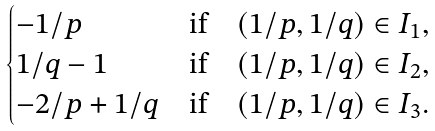Convert formula to latex. <formula><loc_0><loc_0><loc_500><loc_500>\begin{cases} - 1 / p & \text {if} \quad ( 1 / p , 1 / q ) \in I _ { 1 } , \\ 1 / q - 1 & \text {if} \quad ( 1 / p , 1 / q ) \in I _ { 2 } , \\ - 2 / p + 1 / q & \text {if} \quad ( 1 / p , 1 / q ) \in I _ { 3 } . \end{cases}</formula> 